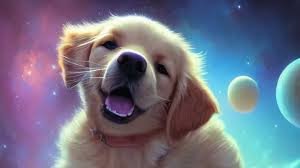Macke the dog smile The dog in the image is already smiling! 🐶😄  It has a happy, open mouth and a playful expression. 